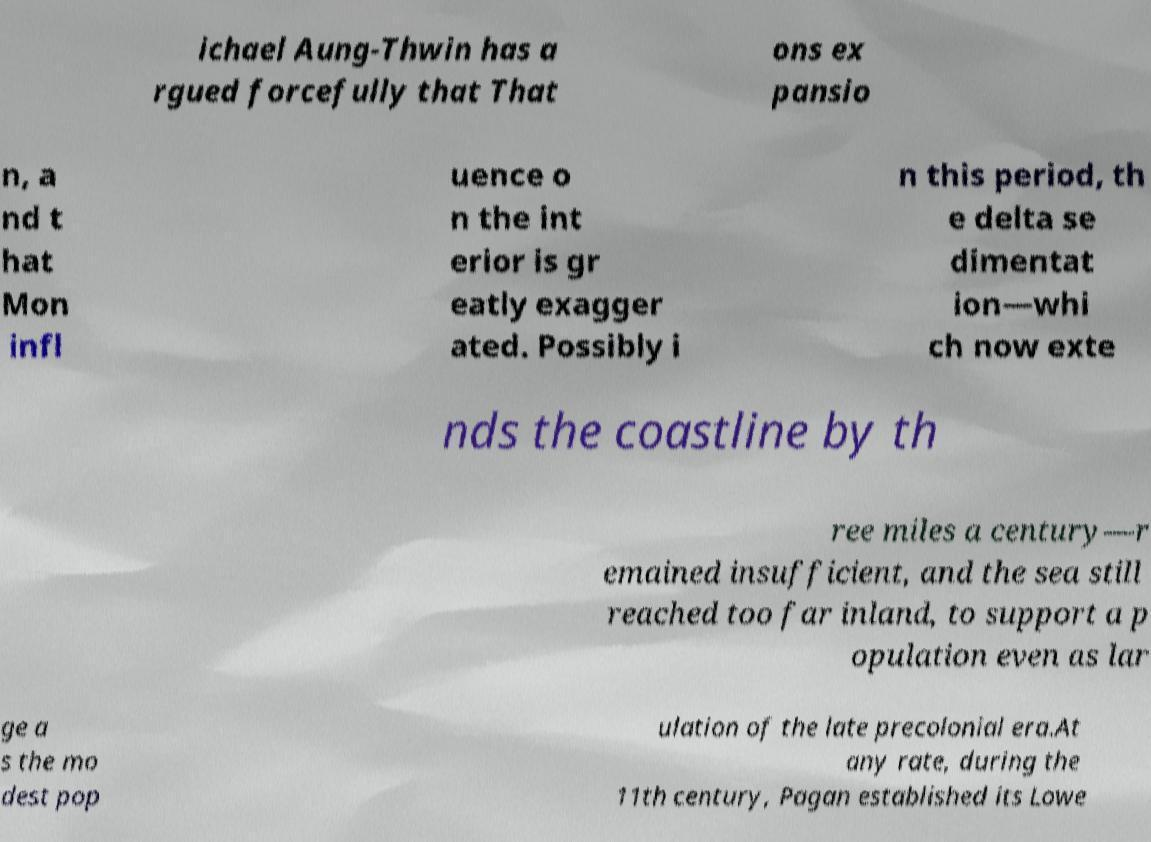Please identify and transcribe the text found in this image. ichael Aung-Thwin has a rgued forcefully that That ons ex pansio n, a nd t hat Mon infl uence o n the int erior is gr eatly exagger ated. Possibly i n this period, th e delta se dimentat ion—whi ch now exte nds the coastline by th ree miles a century—r emained insufficient, and the sea still reached too far inland, to support a p opulation even as lar ge a s the mo dest pop ulation of the late precolonial era.At any rate, during the 11th century, Pagan established its Lowe 